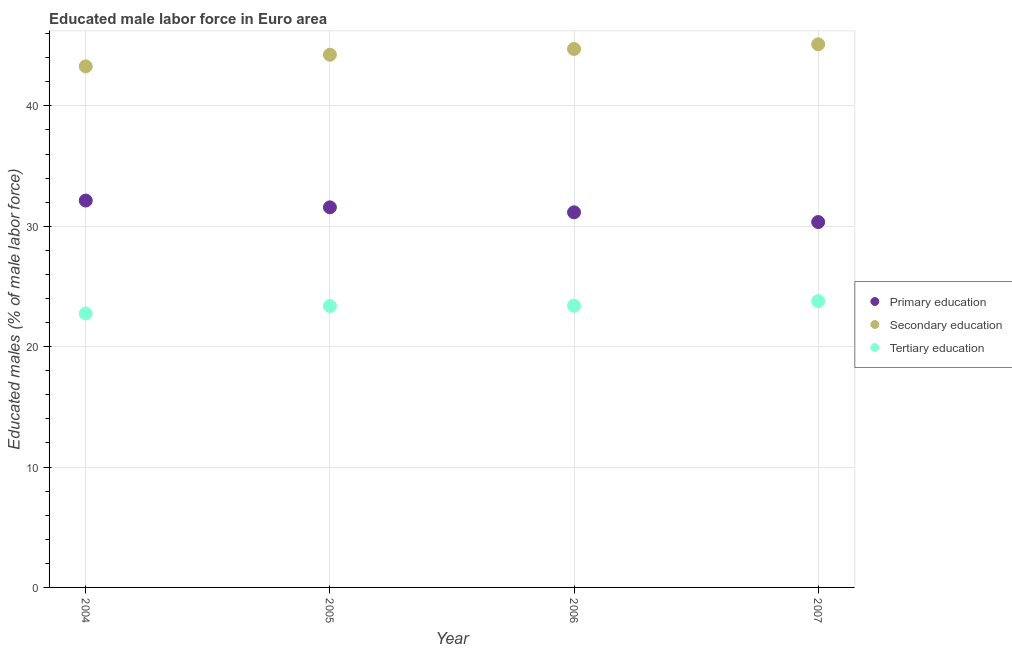How many different coloured dotlines are there?
Provide a succinct answer. 3. What is the percentage of male labor force who received primary education in 2006?
Offer a terse response. 31.16. Across all years, what is the maximum percentage of male labor force who received primary education?
Provide a short and direct response. 32.14. Across all years, what is the minimum percentage of male labor force who received primary education?
Make the answer very short. 30.35. In which year was the percentage of male labor force who received tertiary education maximum?
Provide a short and direct response. 2007. What is the total percentage of male labor force who received secondary education in the graph?
Provide a succinct answer. 177.38. What is the difference between the percentage of male labor force who received primary education in 2004 and that in 2005?
Offer a terse response. 0.57. What is the difference between the percentage of male labor force who received secondary education in 2006 and the percentage of male labor force who received tertiary education in 2005?
Keep it short and to the point. 21.35. What is the average percentage of male labor force who received tertiary education per year?
Make the answer very short. 23.33. In the year 2006, what is the difference between the percentage of male labor force who received tertiary education and percentage of male labor force who received primary education?
Offer a very short reply. -7.76. What is the ratio of the percentage of male labor force who received tertiary education in 2004 to that in 2005?
Provide a succinct answer. 0.97. Is the percentage of male labor force who received tertiary education in 2005 less than that in 2006?
Offer a very short reply. Yes. What is the difference between the highest and the second highest percentage of male labor force who received secondary education?
Provide a short and direct response. 0.39. What is the difference between the highest and the lowest percentage of male labor force who received secondary education?
Your response must be concise. 1.83. Is it the case that in every year, the sum of the percentage of male labor force who received primary education and percentage of male labor force who received secondary education is greater than the percentage of male labor force who received tertiary education?
Provide a short and direct response. Yes. Is the percentage of male labor force who received primary education strictly greater than the percentage of male labor force who received secondary education over the years?
Your response must be concise. No. Is the percentage of male labor force who received tertiary education strictly less than the percentage of male labor force who received secondary education over the years?
Give a very brief answer. Yes. How many dotlines are there?
Offer a very short reply. 3. Are the values on the major ticks of Y-axis written in scientific E-notation?
Keep it short and to the point. No. Does the graph contain any zero values?
Keep it short and to the point. No. How many legend labels are there?
Give a very brief answer. 3. How are the legend labels stacked?
Your answer should be compact. Vertical. What is the title of the graph?
Give a very brief answer. Educated male labor force in Euro area. What is the label or title of the Y-axis?
Make the answer very short. Educated males (% of male labor force). What is the Educated males (% of male labor force) in Primary education in 2004?
Your answer should be compact. 32.14. What is the Educated males (% of male labor force) in Secondary education in 2004?
Ensure brevity in your answer.  43.28. What is the Educated males (% of male labor force) of Tertiary education in 2004?
Offer a very short reply. 22.75. What is the Educated males (% of male labor force) in Primary education in 2005?
Your answer should be very brief. 31.57. What is the Educated males (% of male labor force) in Secondary education in 2005?
Ensure brevity in your answer.  44.25. What is the Educated males (% of male labor force) in Tertiary education in 2005?
Your answer should be compact. 23.38. What is the Educated males (% of male labor force) in Primary education in 2006?
Your response must be concise. 31.16. What is the Educated males (% of male labor force) of Secondary education in 2006?
Your answer should be compact. 44.73. What is the Educated males (% of male labor force) of Tertiary education in 2006?
Your answer should be very brief. 23.4. What is the Educated males (% of male labor force) of Primary education in 2007?
Your answer should be very brief. 30.35. What is the Educated males (% of male labor force) of Secondary education in 2007?
Offer a terse response. 45.12. What is the Educated males (% of male labor force) in Tertiary education in 2007?
Your response must be concise. 23.79. Across all years, what is the maximum Educated males (% of male labor force) of Primary education?
Offer a terse response. 32.14. Across all years, what is the maximum Educated males (% of male labor force) of Secondary education?
Provide a succinct answer. 45.12. Across all years, what is the maximum Educated males (% of male labor force) of Tertiary education?
Your answer should be compact. 23.79. Across all years, what is the minimum Educated males (% of male labor force) in Primary education?
Provide a short and direct response. 30.35. Across all years, what is the minimum Educated males (% of male labor force) in Secondary education?
Provide a short and direct response. 43.28. Across all years, what is the minimum Educated males (% of male labor force) in Tertiary education?
Make the answer very short. 22.75. What is the total Educated males (% of male labor force) in Primary education in the graph?
Keep it short and to the point. 125.22. What is the total Educated males (% of male labor force) of Secondary education in the graph?
Keep it short and to the point. 177.38. What is the total Educated males (% of male labor force) in Tertiary education in the graph?
Ensure brevity in your answer.  93.31. What is the difference between the Educated males (% of male labor force) in Primary education in 2004 and that in 2005?
Your response must be concise. 0.57. What is the difference between the Educated males (% of male labor force) of Secondary education in 2004 and that in 2005?
Offer a terse response. -0.97. What is the difference between the Educated males (% of male labor force) in Tertiary education in 2004 and that in 2005?
Ensure brevity in your answer.  -0.62. What is the difference between the Educated males (% of male labor force) in Primary education in 2004 and that in 2006?
Your answer should be very brief. 0.98. What is the difference between the Educated males (% of male labor force) of Secondary education in 2004 and that in 2006?
Give a very brief answer. -1.45. What is the difference between the Educated males (% of male labor force) of Tertiary education in 2004 and that in 2006?
Keep it short and to the point. -0.65. What is the difference between the Educated males (% of male labor force) of Primary education in 2004 and that in 2007?
Provide a succinct answer. 1.79. What is the difference between the Educated males (% of male labor force) of Secondary education in 2004 and that in 2007?
Keep it short and to the point. -1.83. What is the difference between the Educated males (% of male labor force) of Tertiary education in 2004 and that in 2007?
Offer a terse response. -1.03. What is the difference between the Educated males (% of male labor force) of Primary education in 2005 and that in 2006?
Give a very brief answer. 0.41. What is the difference between the Educated males (% of male labor force) in Secondary education in 2005 and that in 2006?
Ensure brevity in your answer.  -0.48. What is the difference between the Educated males (% of male labor force) in Tertiary education in 2005 and that in 2006?
Keep it short and to the point. -0.02. What is the difference between the Educated males (% of male labor force) of Primary education in 2005 and that in 2007?
Ensure brevity in your answer.  1.22. What is the difference between the Educated males (% of male labor force) in Secondary education in 2005 and that in 2007?
Give a very brief answer. -0.87. What is the difference between the Educated males (% of male labor force) in Tertiary education in 2005 and that in 2007?
Your answer should be compact. -0.41. What is the difference between the Educated males (% of male labor force) of Primary education in 2006 and that in 2007?
Provide a short and direct response. 0.81. What is the difference between the Educated males (% of male labor force) in Secondary education in 2006 and that in 2007?
Make the answer very short. -0.39. What is the difference between the Educated males (% of male labor force) of Tertiary education in 2006 and that in 2007?
Make the answer very short. -0.39. What is the difference between the Educated males (% of male labor force) in Primary education in 2004 and the Educated males (% of male labor force) in Secondary education in 2005?
Ensure brevity in your answer.  -12.11. What is the difference between the Educated males (% of male labor force) in Primary education in 2004 and the Educated males (% of male labor force) in Tertiary education in 2005?
Offer a very short reply. 8.76. What is the difference between the Educated males (% of male labor force) in Secondary education in 2004 and the Educated males (% of male labor force) in Tertiary education in 2005?
Your answer should be compact. 19.91. What is the difference between the Educated males (% of male labor force) in Primary education in 2004 and the Educated males (% of male labor force) in Secondary education in 2006?
Your response must be concise. -12.59. What is the difference between the Educated males (% of male labor force) in Primary education in 2004 and the Educated males (% of male labor force) in Tertiary education in 2006?
Keep it short and to the point. 8.74. What is the difference between the Educated males (% of male labor force) of Secondary education in 2004 and the Educated males (% of male labor force) of Tertiary education in 2006?
Provide a short and direct response. 19.88. What is the difference between the Educated males (% of male labor force) in Primary education in 2004 and the Educated males (% of male labor force) in Secondary education in 2007?
Give a very brief answer. -12.98. What is the difference between the Educated males (% of male labor force) in Primary education in 2004 and the Educated males (% of male labor force) in Tertiary education in 2007?
Keep it short and to the point. 8.35. What is the difference between the Educated males (% of male labor force) in Secondary education in 2004 and the Educated males (% of male labor force) in Tertiary education in 2007?
Your answer should be very brief. 19.5. What is the difference between the Educated males (% of male labor force) of Primary education in 2005 and the Educated males (% of male labor force) of Secondary education in 2006?
Ensure brevity in your answer.  -13.16. What is the difference between the Educated males (% of male labor force) in Primary education in 2005 and the Educated males (% of male labor force) in Tertiary education in 2006?
Your answer should be compact. 8.17. What is the difference between the Educated males (% of male labor force) in Secondary education in 2005 and the Educated males (% of male labor force) in Tertiary education in 2006?
Provide a succinct answer. 20.85. What is the difference between the Educated males (% of male labor force) of Primary education in 2005 and the Educated males (% of male labor force) of Secondary education in 2007?
Make the answer very short. -13.54. What is the difference between the Educated males (% of male labor force) in Primary education in 2005 and the Educated males (% of male labor force) in Tertiary education in 2007?
Offer a very short reply. 7.79. What is the difference between the Educated males (% of male labor force) in Secondary education in 2005 and the Educated males (% of male labor force) in Tertiary education in 2007?
Your answer should be very brief. 20.46. What is the difference between the Educated males (% of male labor force) in Primary education in 2006 and the Educated males (% of male labor force) in Secondary education in 2007?
Offer a terse response. -13.96. What is the difference between the Educated males (% of male labor force) of Primary education in 2006 and the Educated males (% of male labor force) of Tertiary education in 2007?
Keep it short and to the point. 7.37. What is the difference between the Educated males (% of male labor force) of Secondary education in 2006 and the Educated males (% of male labor force) of Tertiary education in 2007?
Offer a very short reply. 20.94. What is the average Educated males (% of male labor force) of Primary education per year?
Your answer should be compact. 31.31. What is the average Educated males (% of male labor force) of Secondary education per year?
Offer a very short reply. 44.34. What is the average Educated males (% of male labor force) in Tertiary education per year?
Make the answer very short. 23.33. In the year 2004, what is the difference between the Educated males (% of male labor force) in Primary education and Educated males (% of male labor force) in Secondary education?
Keep it short and to the point. -11.14. In the year 2004, what is the difference between the Educated males (% of male labor force) in Primary education and Educated males (% of male labor force) in Tertiary education?
Provide a succinct answer. 9.39. In the year 2004, what is the difference between the Educated males (% of male labor force) of Secondary education and Educated males (% of male labor force) of Tertiary education?
Offer a terse response. 20.53. In the year 2005, what is the difference between the Educated males (% of male labor force) of Primary education and Educated males (% of male labor force) of Secondary education?
Offer a very short reply. -12.68. In the year 2005, what is the difference between the Educated males (% of male labor force) of Primary education and Educated males (% of male labor force) of Tertiary education?
Offer a terse response. 8.2. In the year 2005, what is the difference between the Educated males (% of male labor force) of Secondary education and Educated males (% of male labor force) of Tertiary education?
Your response must be concise. 20.87. In the year 2006, what is the difference between the Educated males (% of male labor force) in Primary education and Educated males (% of male labor force) in Secondary education?
Make the answer very short. -13.57. In the year 2006, what is the difference between the Educated males (% of male labor force) of Primary education and Educated males (% of male labor force) of Tertiary education?
Give a very brief answer. 7.76. In the year 2006, what is the difference between the Educated males (% of male labor force) in Secondary education and Educated males (% of male labor force) in Tertiary education?
Your answer should be very brief. 21.33. In the year 2007, what is the difference between the Educated males (% of male labor force) of Primary education and Educated males (% of male labor force) of Secondary education?
Provide a short and direct response. -14.76. In the year 2007, what is the difference between the Educated males (% of male labor force) in Primary education and Educated males (% of male labor force) in Tertiary education?
Your response must be concise. 6.57. In the year 2007, what is the difference between the Educated males (% of male labor force) in Secondary education and Educated males (% of male labor force) in Tertiary education?
Give a very brief answer. 21.33. What is the ratio of the Educated males (% of male labor force) in Primary education in 2004 to that in 2005?
Your answer should be compact. 1.02. What is the ratio of the Educated males (% of male labor force) in Secondary education in 2004 to that in 2005?
Your answer should be very brief. 0.98. What is the ratio of the Educated males (% of male labor force) of Tertiary education in 2004 to that in 2005?
Provide a succinct answer. 0.97. What is the ratio of the Educated males (% of male labor force) of Primary education in 2004 to that in 2006?
Provide a short and direct response. 1.03. What is the ratio of the Educated males (% of male labor force) in Secondary education in 2004 to that in 2006?
Offer a very short reply. 0.97. What is the ratio of the Educated males (% of male labor force) in Tertiary education in 2004 to that in 2006?
Provide a succinct answer. 0.97. What is the ratio of the Educated males (% of male labor force) of Primary education in 2004 to that in 2007?
Your answer should be very brief. 1.06. What is the ratio of the Educated males (% of male labor force) of Secondary education in 2004 to that in 2007?
Offer a very short reply. 0.96. What is the ratio of the Educated males (% of male labor force) of Tertiary education in 2004 to that in 2007?
Ensure brevity in your answer.  0.96. What is the ratio of the Educated males (% of male labor force) of Primary education in 2005 to that in 2006?
Your response must be concise. 1.01. What is the ratio of the Educated males (% of male labor force) of Secondary education in 2005 to that in 2006?
Your answer should be compact. 0.99. What is the ratio of the Educated males (% of male labor force) of Tertiary education in 2005 to that in 2006?
Provide a succinct answer. 1. What is the ratio of the Educated males (% of male labor force) in Primary education in 2005 to that in 2007?
Your answer should be compact. 1.04. What is the ratio of the Educated males (% of male labor force) of Secondary education in 2005 to that in 2007?
Your answer should be very brief. 0.98. What is the ratio of the Educated males (% of male labor force) in Tertiary education in 2005 to that in 2007?
Offer a very short reply. 0.98. What is the ratio of the Educated males (% of male labor force) of Primary education in 2006 to that in 2007?
Make the answer very short. 1.03. What is the ratio of the Educated males (% of male labor force) of Tertiary education in 2006 to that in 2007?
Give a very brief answer. 0.98. What is the difference between the highest and the second highest Educated males (% of male labor force) of Primary education?
Your response must be concise. 0.57. What is the difference between the highest and the second highest Educated males (% of male labor force) of Secondary education?
Ensure brevity in your answer.  0.39. What is the difference between the highest and the second highest Educated males (% of male labor force) in Tertiary education?
Keep it short and to the point. 0.39. What is the difference between the highest and the lowest Educated males (% of male labor force) of Primary education?
Ensure brevity in your answer.  1.79. What is the difference between the highest and the lowest Educated males (% of male labor force) in Secondary education?
Ensure brevity in your answer.  1.83. What is the difference between the highest and the lowest Educated males (% of male labor force) of Tertiary education?
Provide a short and direct response. 1.03. 